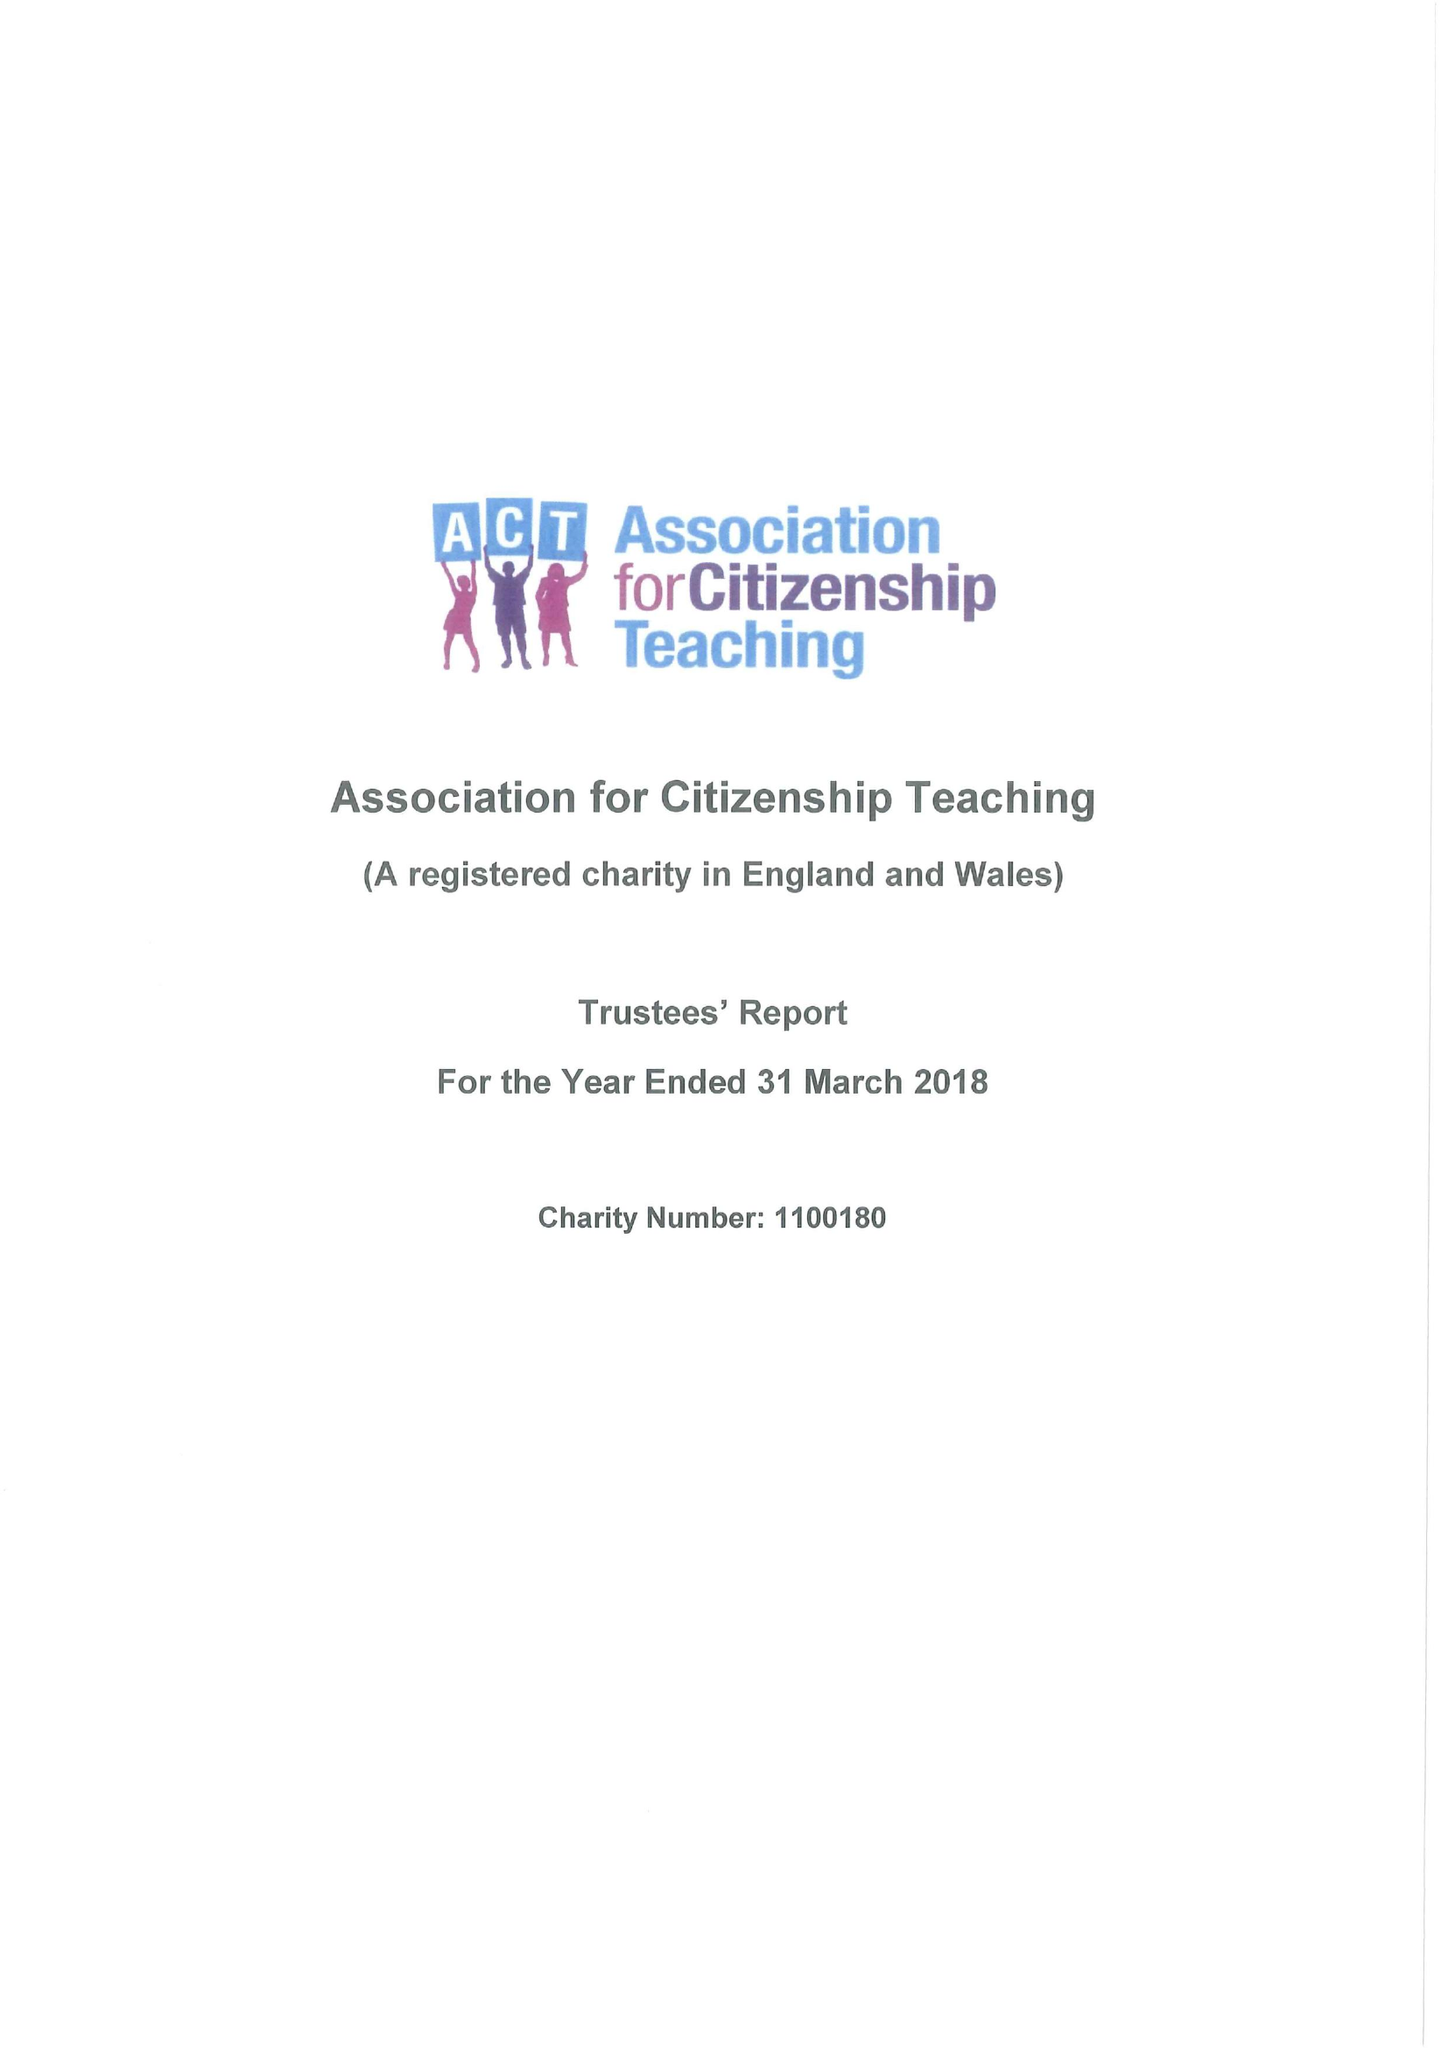What is the value for the address__post_town?
Answer the question using a single word or phrase. LONDON 